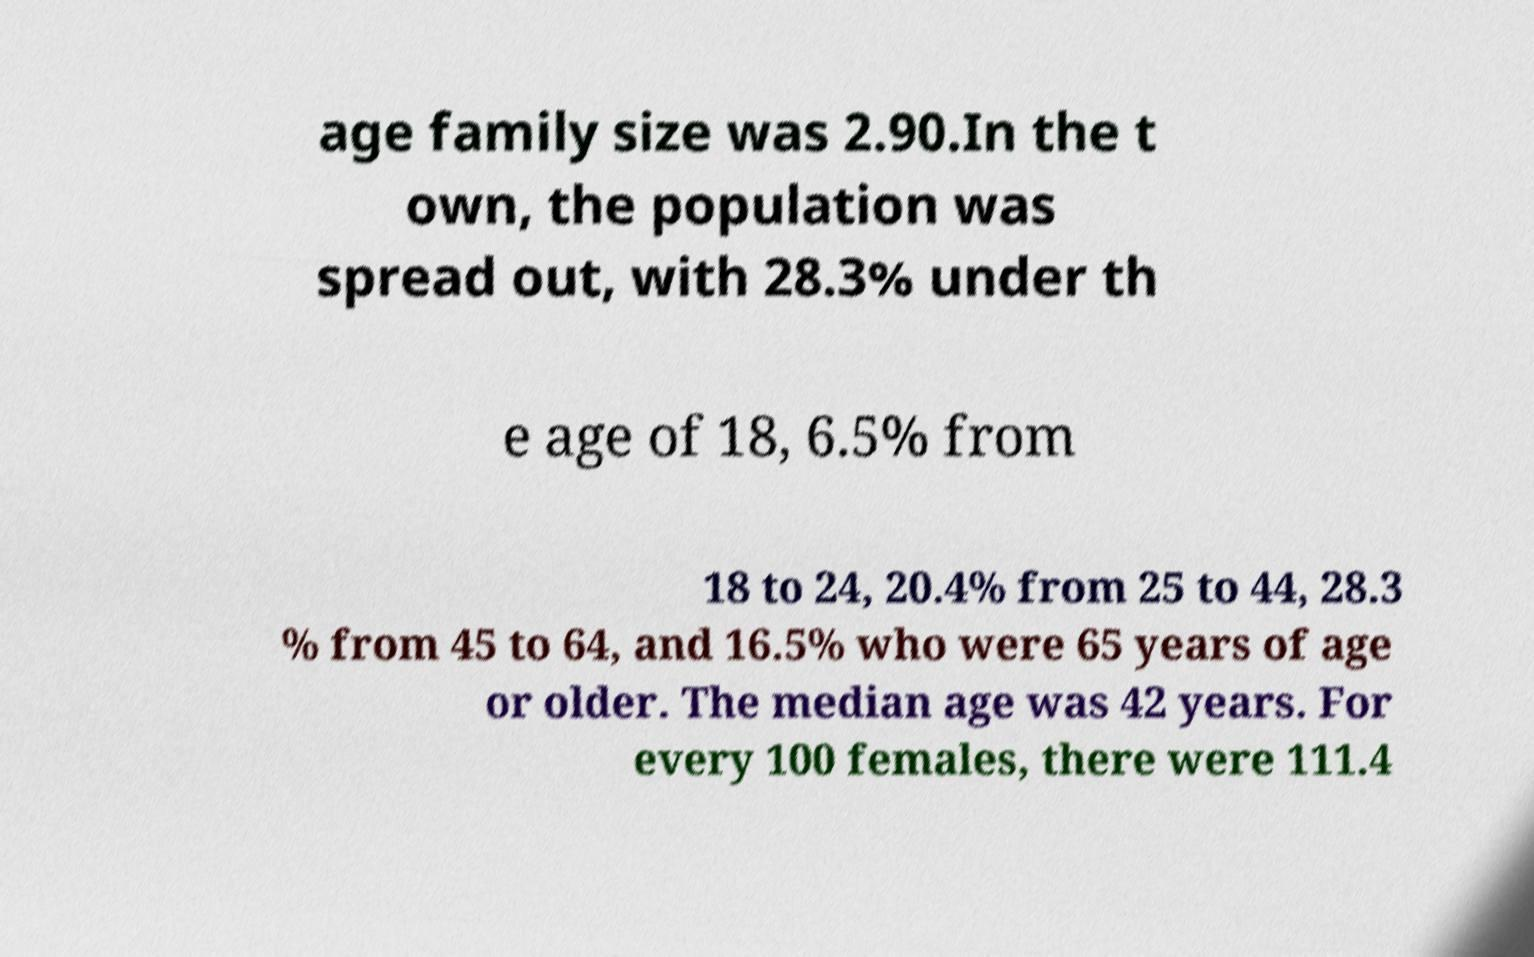Could you extract and type out the text from this image? age family size was 2.90.In the t own, the population was spread out, with 28.3% under th e age of 18, 6.5% from 18 to 24, 20.4% from 25 to 44, 28.3 % from 45 to 64, and 16.5% who were 65 years of age or older. The median age was 42 years. For every 100 females, there were 111.4 